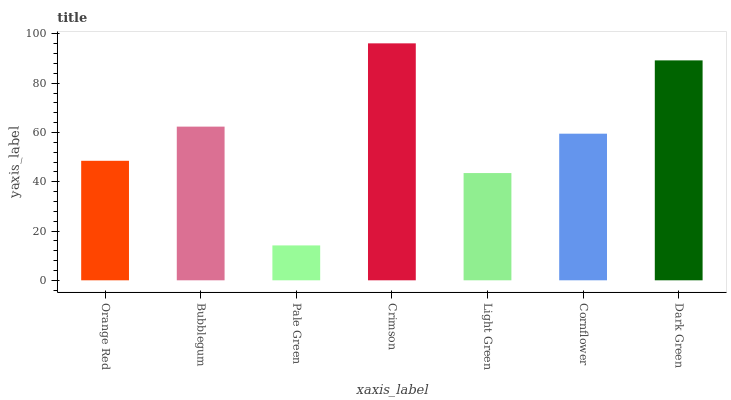Is Pale Green the minimum?
Answer yes or no. Yes. Is Crimson the maximum?
Answer yes or no. Yes. Is Bubblegum the minimum?
Answer yes or no. No. Is Bubblegum the maximum?
Answer yes or no. No. Is Bubblegum greater than Orange Red?
Answer yes or no. Yes. Is Orange Red less than Bubblegum?
Answer yes or no. Yes. Is Orange Red greater than Bubblegum?
Answer yes or no. No. Is Bubblegum less than Orange Red?
Answer yes or no. No. Is Cornflower the high median?
Answer yes or no. Yes. Is Cornflower the low median?
Answer yes or no. Yes. Is Crimson the high median?
Answer yes or no. No. Is Orange Red the low median?
Answer yes or no. No. 